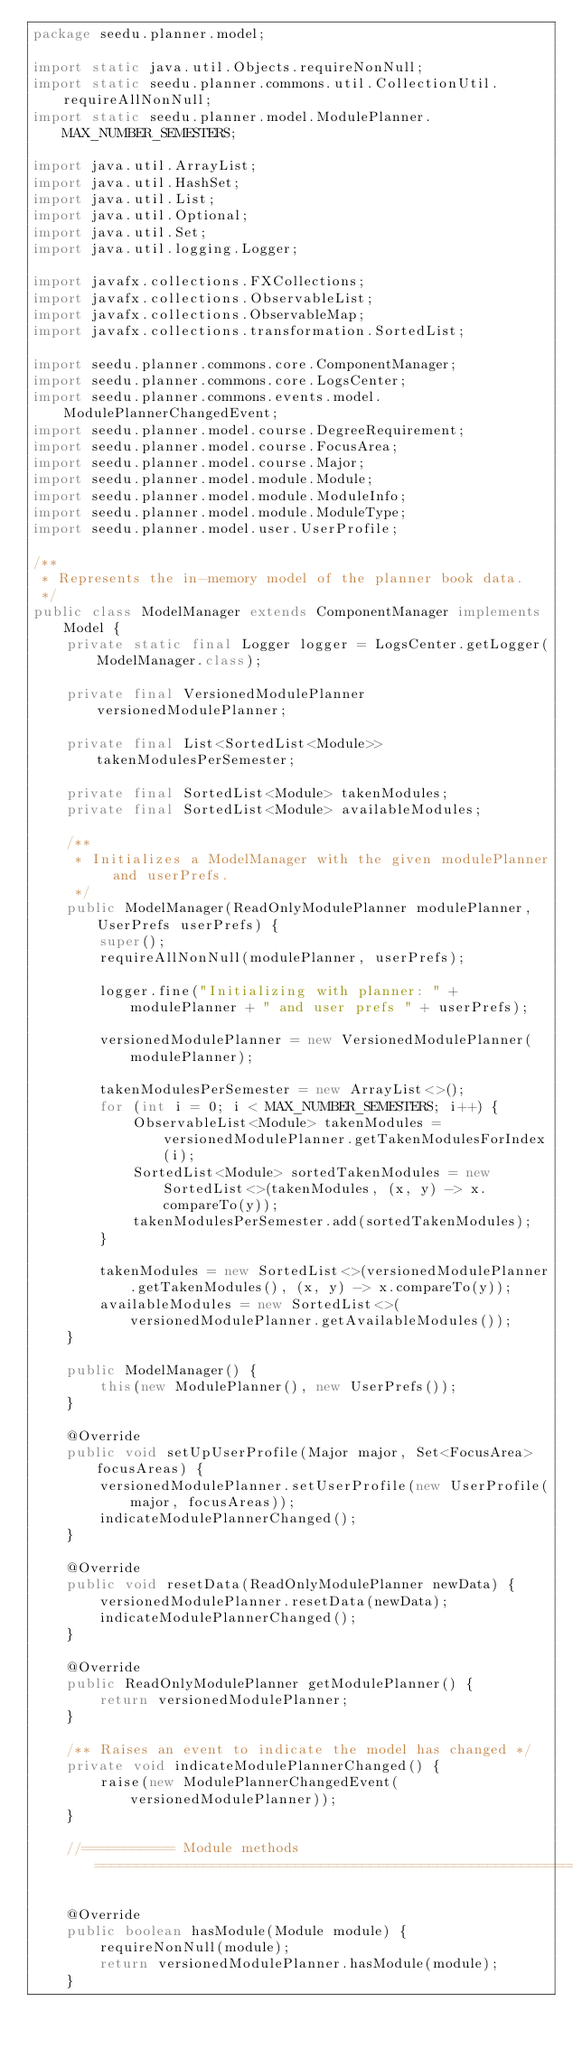Convert code to text. <code><loc_0><loc_0><loc_500><loc_500><_Java_>package seedu.planner.model;

import static java.util.Objects.requireNonNull;
import static seedu.planner.commons.util.CollectionUtil.requireAllNonNull;
import static seedu.planner.model.ModulePlanner.MAX_NUMBER_SEMESTERS;

import java.util.ArrayList;
import java.util.HashSet;
import java.util.List;
import java.util.Optional;
import java.util.Set;
import java.util.logging.Logger;

import javafx.collections.FXCollections;
import javafx.collections.ObservableList;
import javafx.collections.ObservableMap;
import javafx.collections.transformation.SortedList;

import seedu.planner.commons.core.ComponentManager;
import seedu.planner.commons.core.LogsCenter;
import seedu.planner.commons.events.model.ModulePlannerChangedEvent;
import seedu.planner.model.course.DegreeRequirement;
import seedu.planner.model.course.FocusArea;
import seedu.planner.model.course.Major;
import seedu.planner.model.module.Module;
import seedu.planner.model.module.ModuleInfo;
import seedu.planner.model.module.ModuleType;
import seedu.planner.model.user.UserProfile;

/**
 * Represents the in-memory model of the planner book data.
 */
public class ModelManager extends ComponentManager implements Model {
    private static final Logger logger = LogsCenter.getLogger(ModelManager.class);

    private final VersionedModulePlanner versionedModulePlanner;

    private final List<SortedList<Module>> takenModulesPerSemester;

    private final SortedList<Module> takenModules;
    private final SortedList<Module> availableModules;

    /**
     * Initializes a ModelManager with the given modulePlanner and userPrefs.
     */
    public ModelManager(ReadOnlyModulePlanner modulePlanner, UserPrefs userPrefs) {
        super();
        requireAllNonNull(modulePlanner, userPrefs);

        logger.fine("Initializing with planner: " + modulePlanner + " and user prefs " + userPrefs);

        versionedModulePlanner = new VersionedModulePlanner(modulePlanner);

        takenModulesPerSemester = new ArrayList<>();
        for (int i = 0; i < MAX_NUMBER_SEMESTERS; i++) {
            ObservableList<Module> takenModules = versionedModulePlanner.getTakenModulesForIndex(i);
            SortedList<Module> sortedTakenModules = new SortedList<>(takenModules, (x, y) -> x.compareTo(y));
            takenModulesPerSemester.add(sortedTakenModules);
        }

        takenModules = new SortedList<>(versionedModulePlanner.getTakenModules(), (x, y) -> x.compareTo(y));
        availableModules = new SortedList<>(versionedModulePlanner.getAvailableModules());
    }

    public ModelManager() {
        this(new ModulePlanner(), new UserPrefs());
    }

    @Override
    public void setUpUserProfile(Major major, Set<FocusArea> focusAreas) {
        versionedModulePlanner.setUserProfile(new UserProfile(major, focusAreas));
        indicateModulePlannerChanged();
    }

    @Override
    public void resetData(ReadOnlyModulePlanner newData) {
        versionedModulePlanner.resetData(newData);
        indicateModulePlannerChanged();
    }

    @Override
    public ReadOnlyModulePlanner getModulePlanner() {
        return versionedModulePlanner;
    }

    /** Raises an event to indicate the model has changed */
    private void indicateModulePlannerChanged() {
        raise(new ModulePlannerChangedEvent(versionedModulePlanner));
    }

    //=========== Module methods =============================================================================

    @Override
    public boolean hasModule(Module module) {
        requireNonNull(module);
        return versionedModulePlanner.hasModule(module);
    }
</code> 